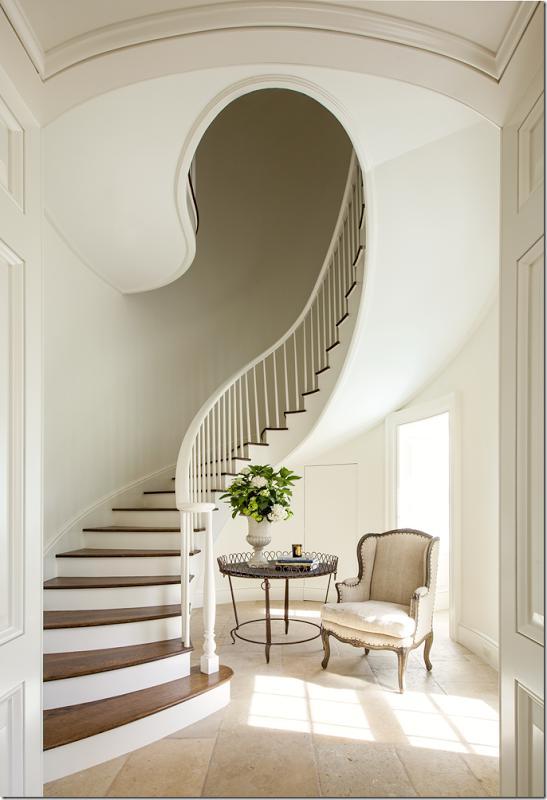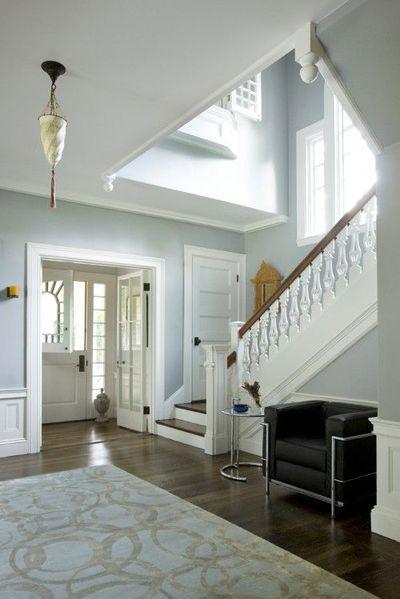The first image is the image on the left, the second image is the image on the right. Considering the images on both sides, is "The left image shows a curving staircase with a curving rail on the right side." valid? Answer yes or no. Yes. The first image is the image on the left, the second image is the image on the right. Evaluate the accuracy of this statement regarding the images: "One staircase's railing is white and the other's is black.". Is it true? Answer yes or no. No. 